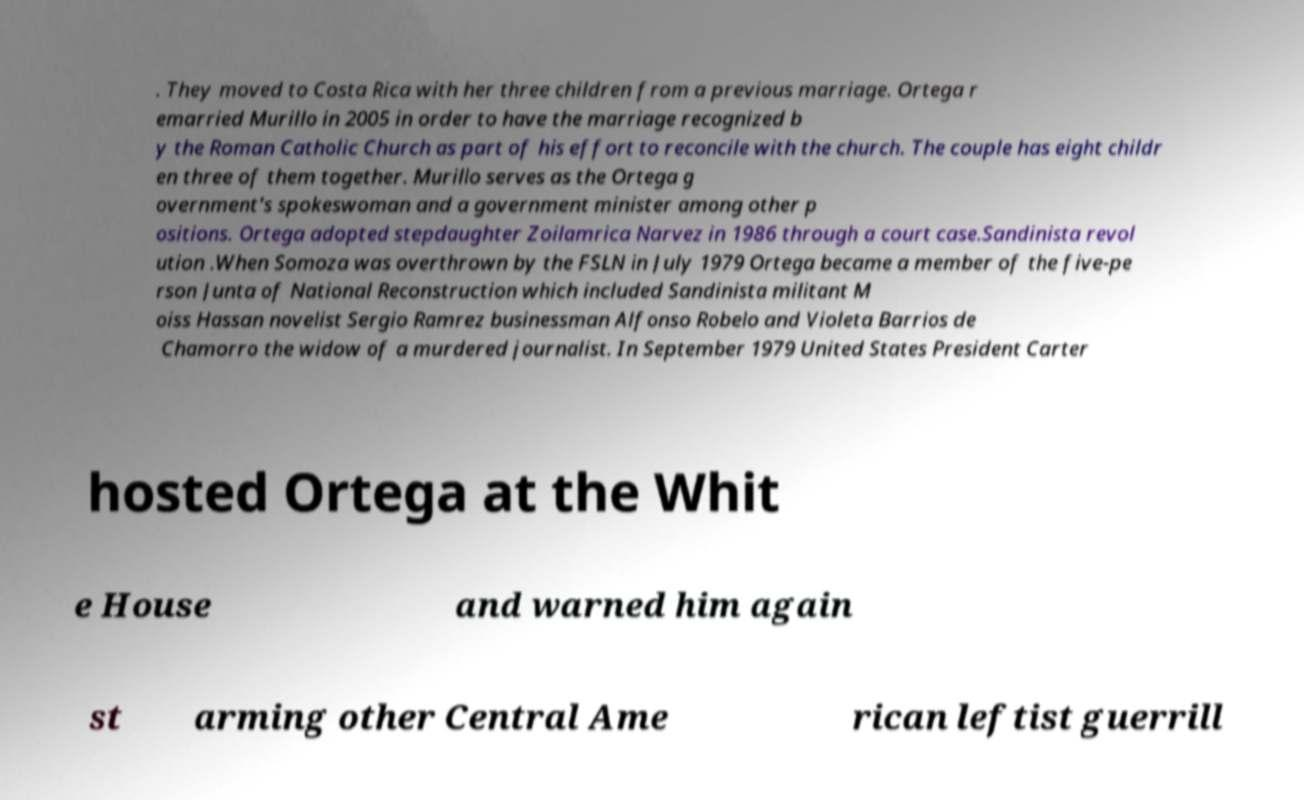Could you extract and type out the text from this image? . They moved to Costa Rica with her three children from a previous marriage. Ortega r emarried Murillo in 2005 in order to have the marriage recognized b y the Roman Catholic Church as part of his effort to reconcile with the church. The couple has eight childr en three of them together. Murillo serves as the Ortega g overnment's spokeswoman and a government minister among other p ositions. Ortega adopted stepdaughter Zoilamrica Narvez in 1986 through a court case.Sandinista revol ution .When Somoza was overthrown by the FSLN in July 1979 Ortega became a member of the five-pe rson Junta of National Reconstruction which included Sandinista militant M oiss Hassan novelist Sergio Ramrez businessman Alfonso Robelo and Violeta Barrios de Chamorro the widow of a murdered journalist. In September 1979 United States President Carter hosted Ortega at the Whit e House and warned him again st arming other Central Ame rican leftist guerrill 